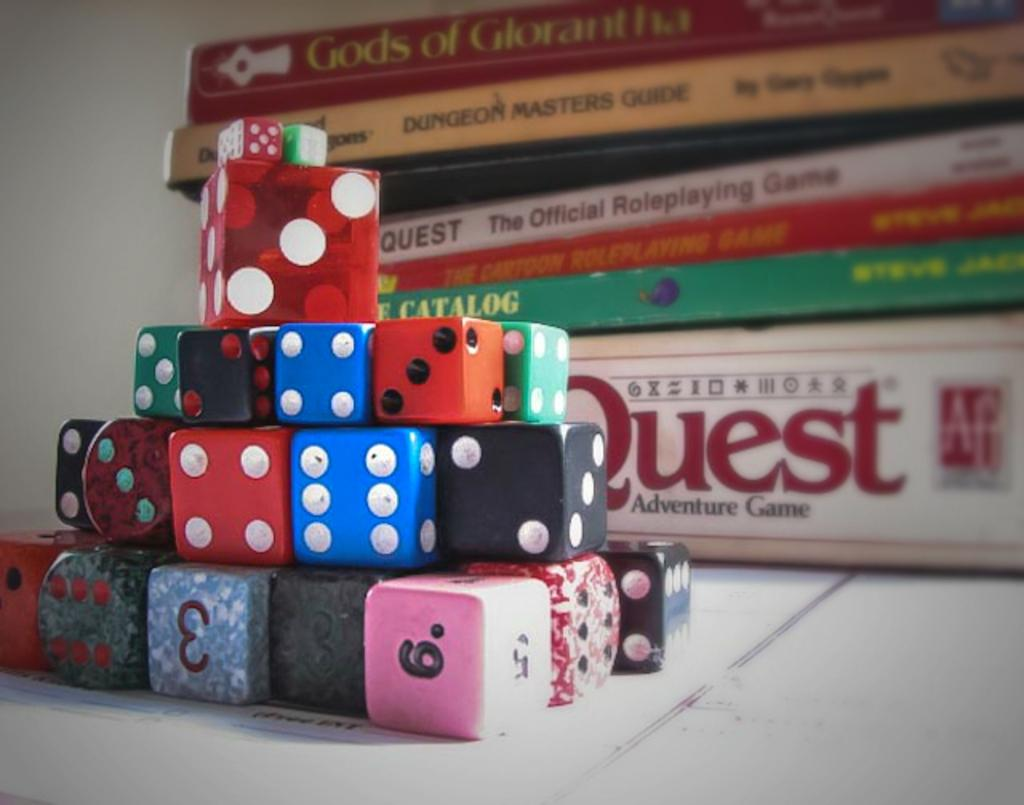<image>
Summarize the visual content of the image. a bunch of dice in a pile in front of a quest adventure game box 